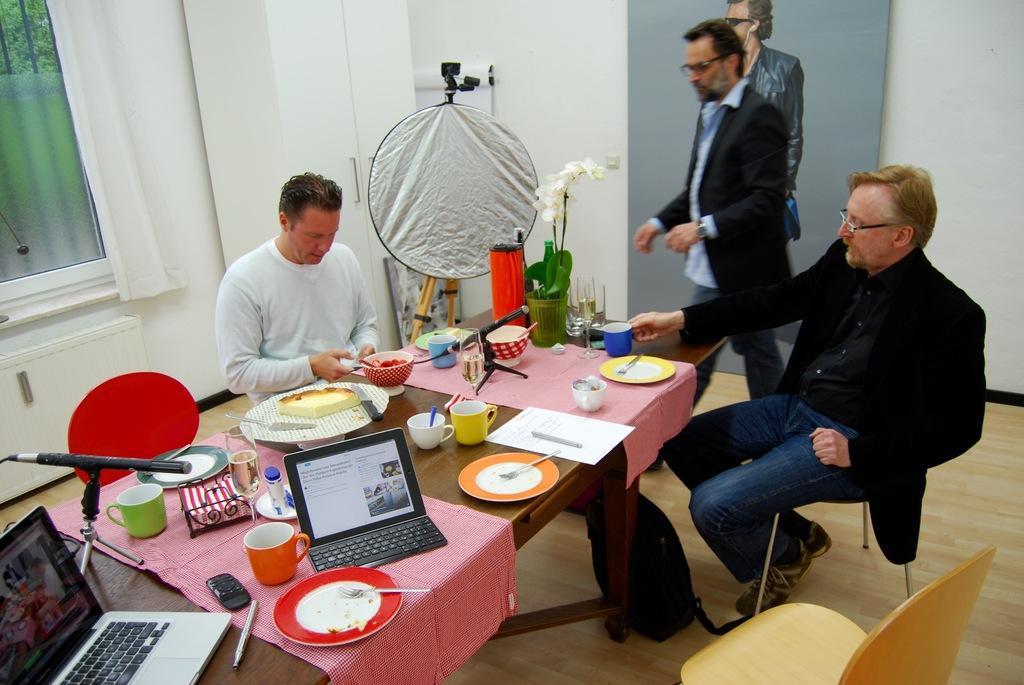Describe this image in one or two sentences. Here we can see a person is standing, and two persons are sitting, and in front here is the table and plates and laptop and many objects on it, and here is the poster, and here is the wall. 